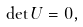<formula> <loc_0><loc_0><loc_500><loc_500>\det U = 0 ,</formula> 